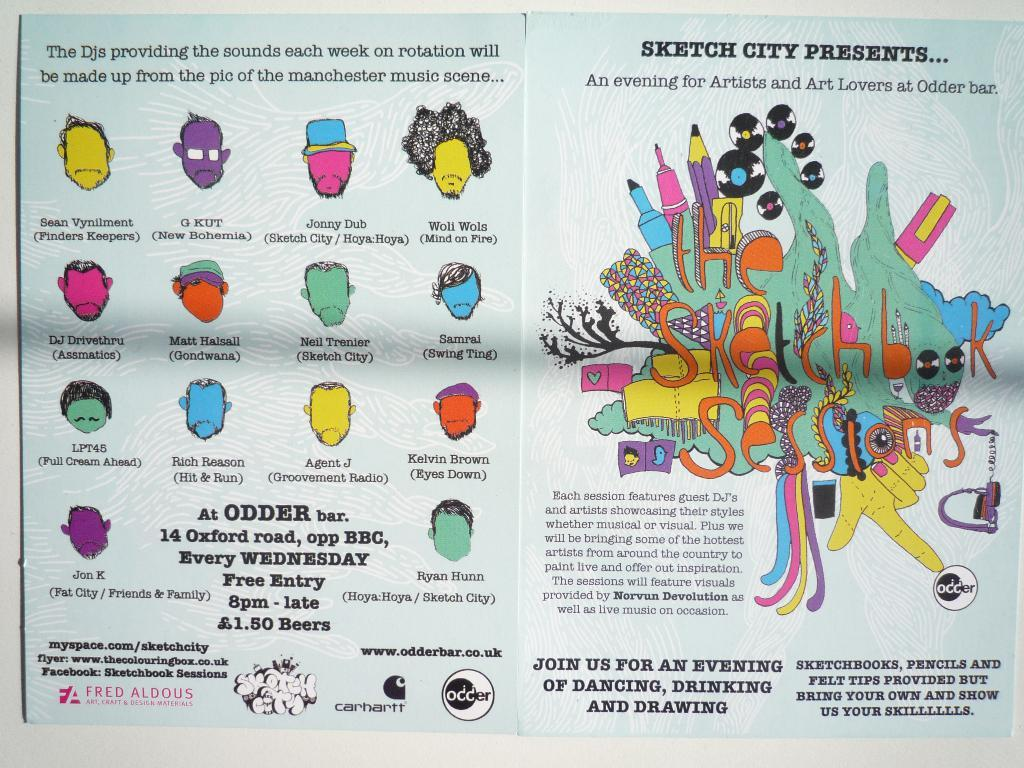<image>
Present a compact description of the photo's key features. An ad by Sketch City about Odder Bar. 